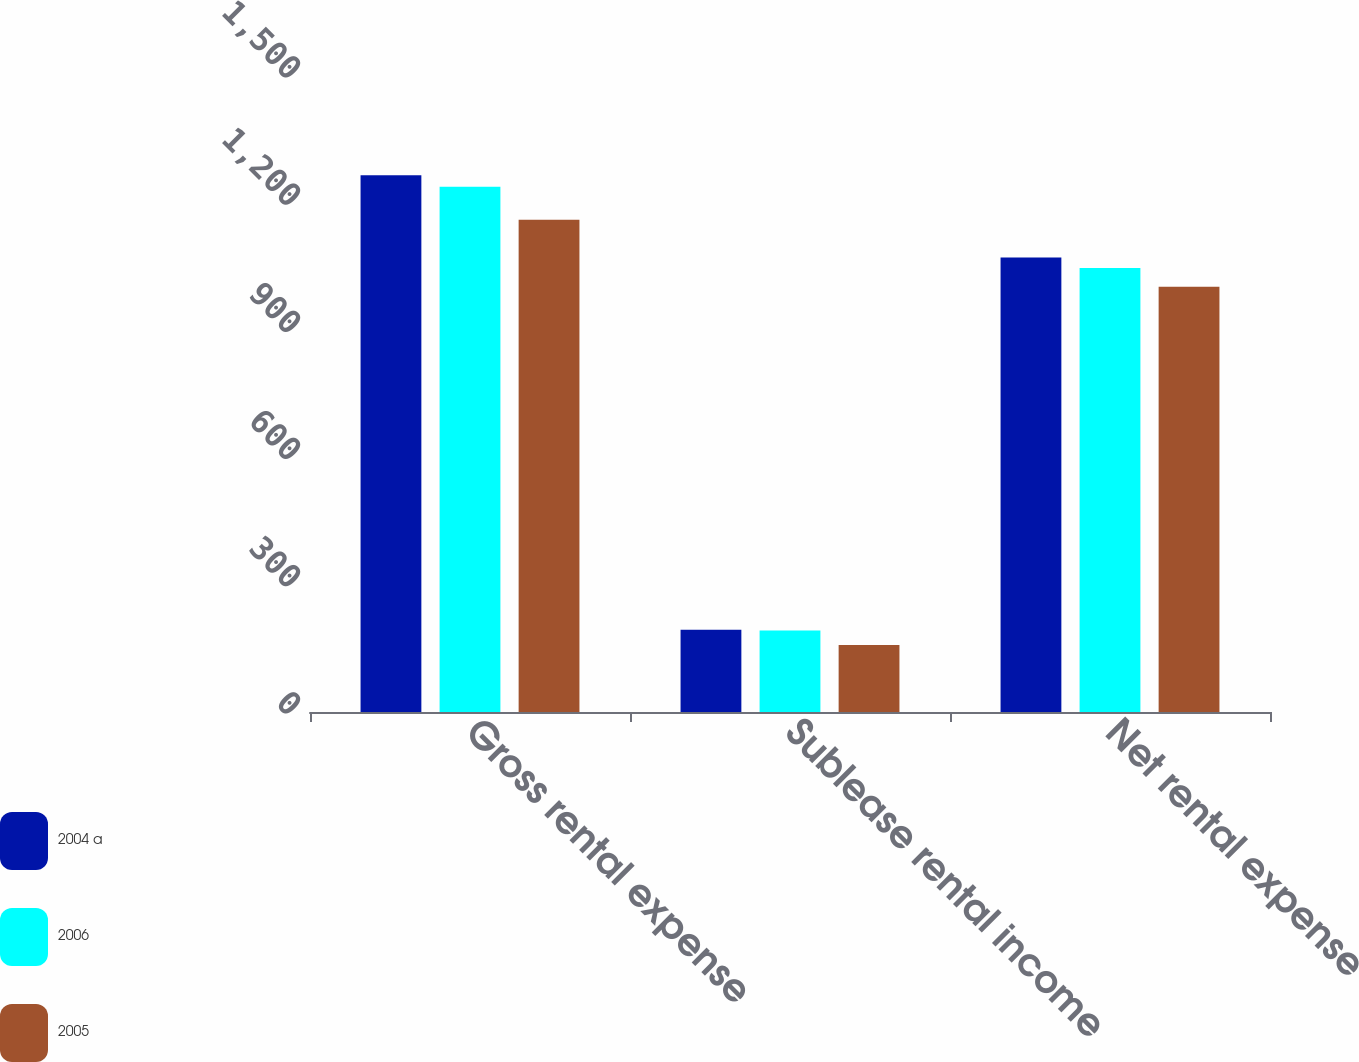<chart> <loc_0><loc_0><loc_500><loc_500><stacked_bar_chart><ecel><fcel>Gross rental expense<fcel>Sublease rental income<fcel>Net rental expense<nl><fcel>2004 a<fcel>1266<fcel>194<fcel>1072<nl><fcel>2006<fcel>1239<fcel>192<fcel>1047<nl><fcel>2005<fcel>1161<fcel>158<fcel>1003<nl></chart> 